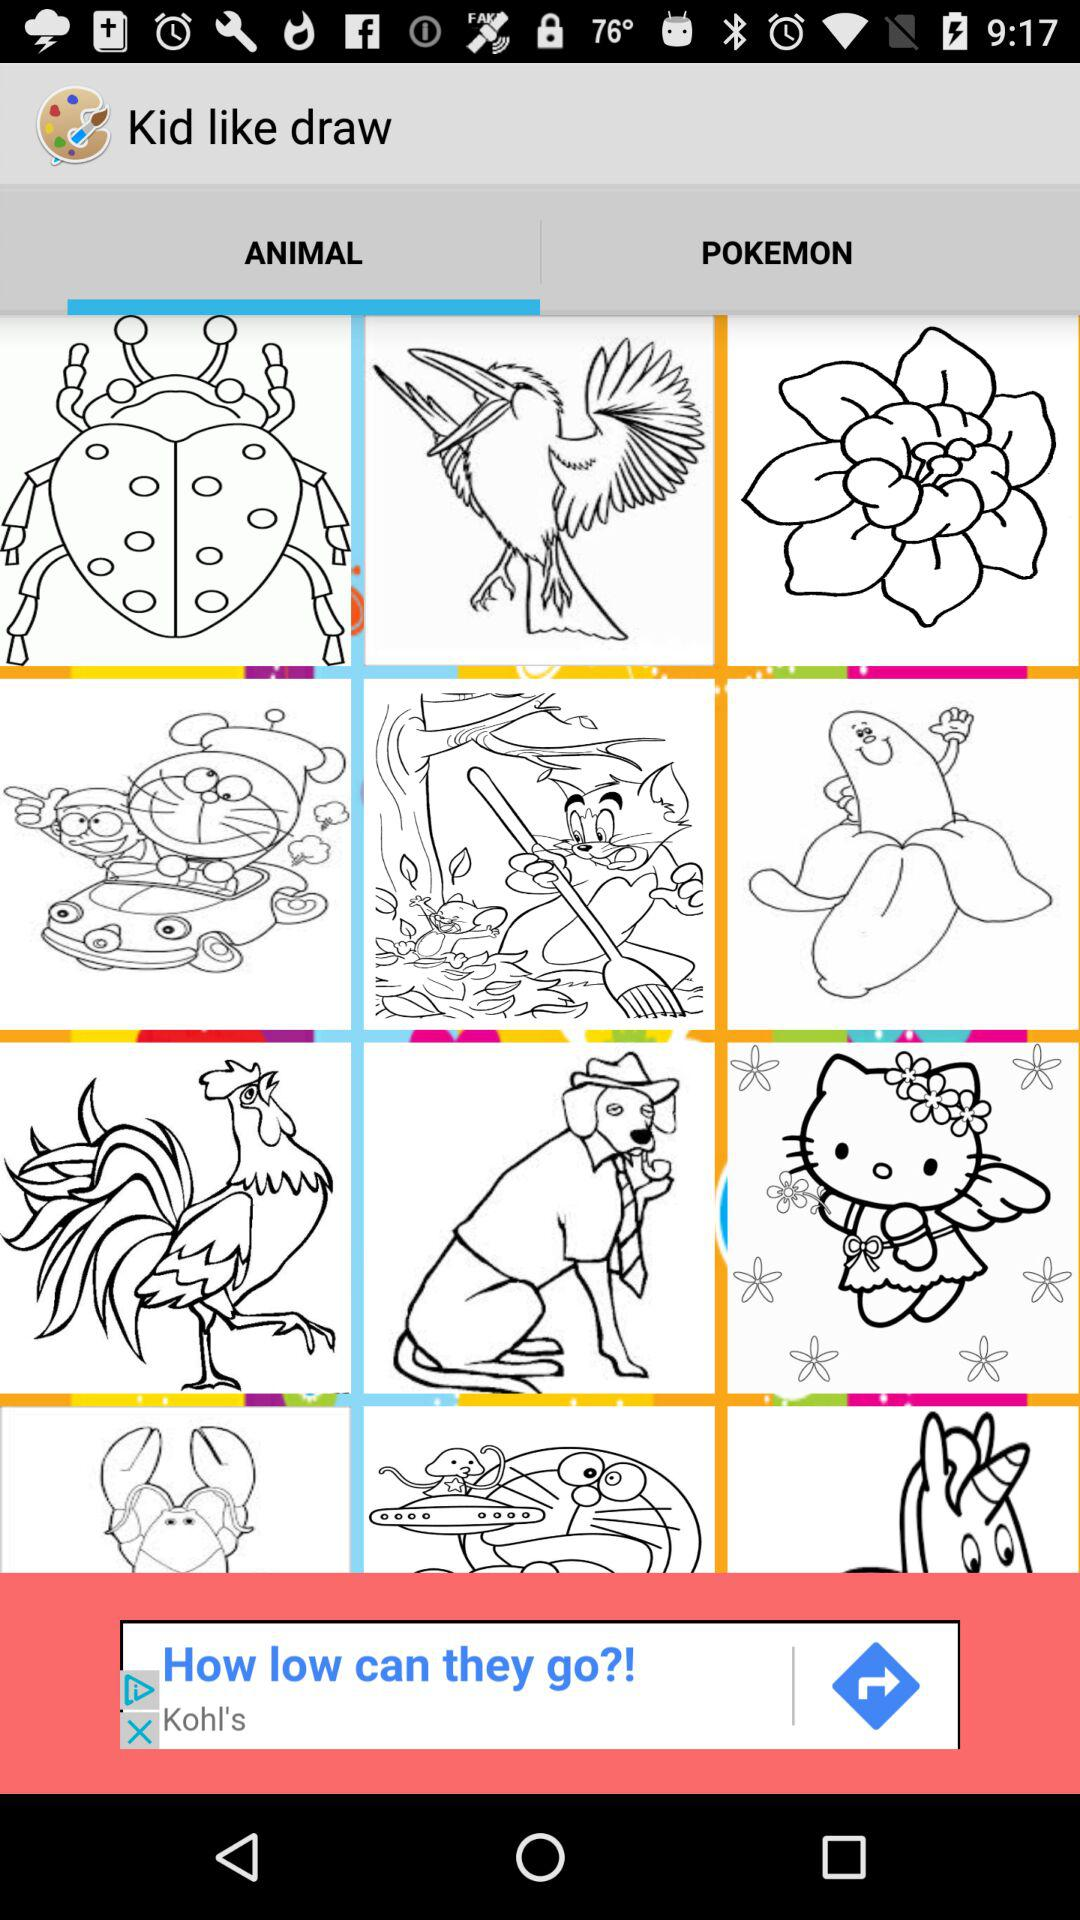What is the application name? The application name is "Kid like draw". 